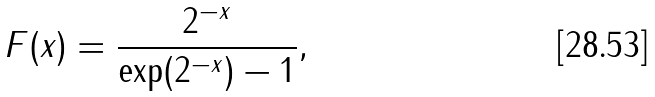<formula> <loc_0><loc_0><loc_500><loc_500>F ( x ) = \frac { 2 ^ { - x } } { \exp ( 2 ^ { - x } ) - 1 } ,</formula> 